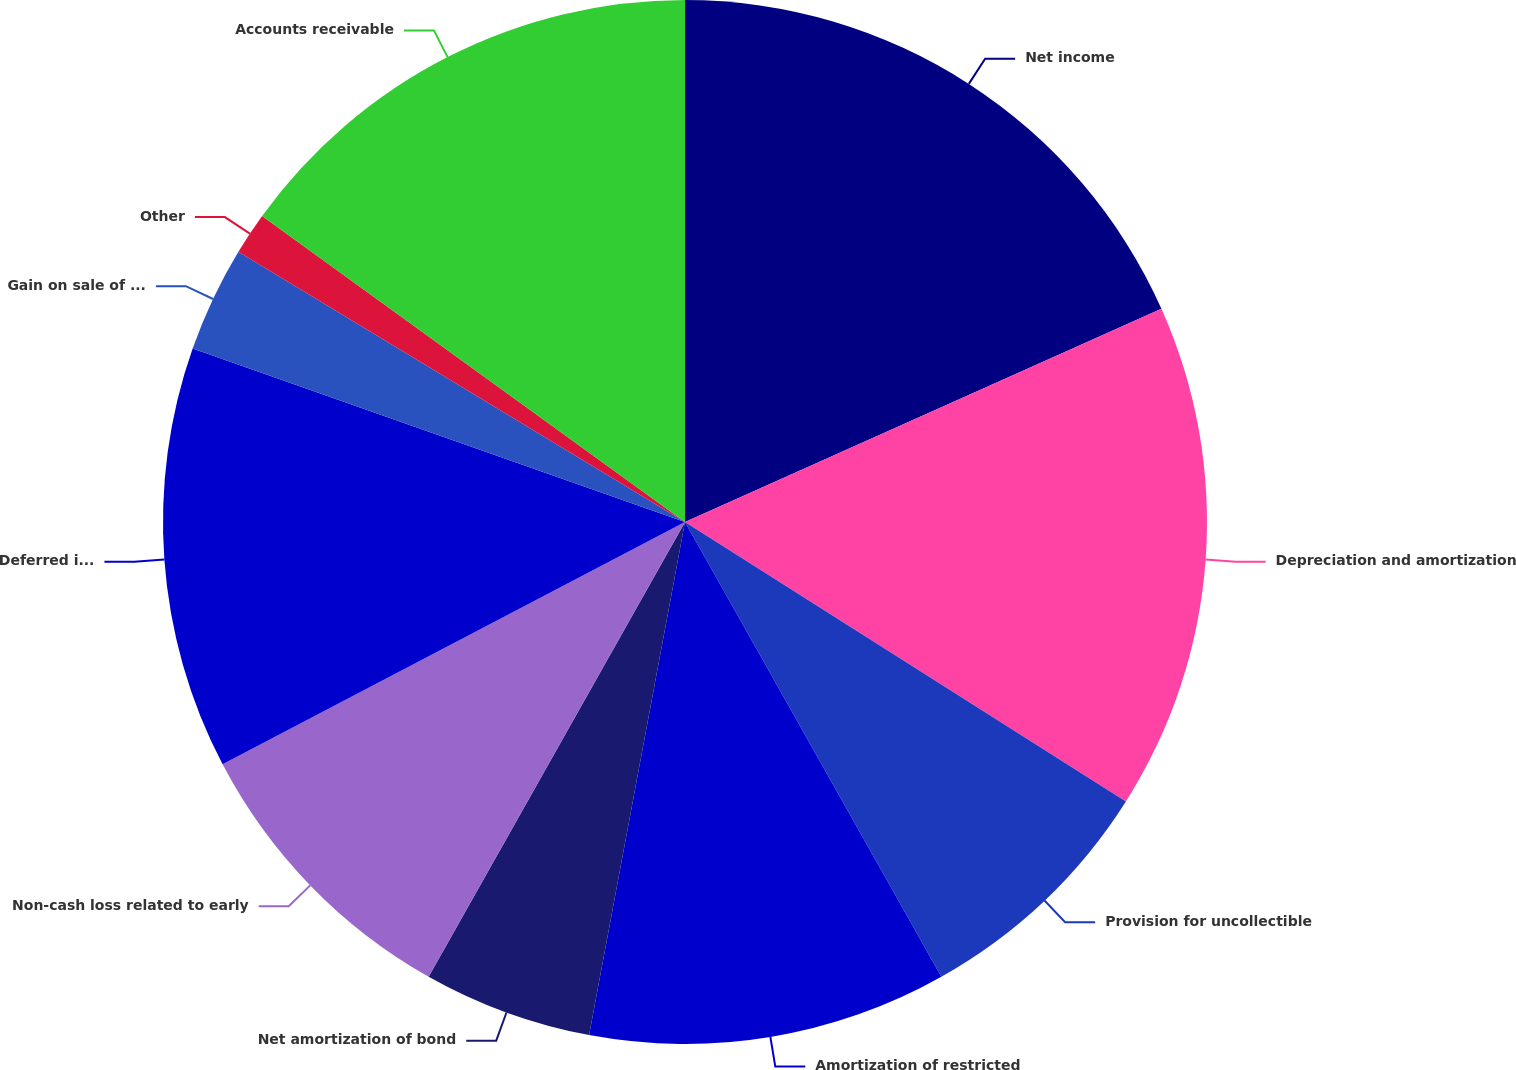<chart> <loc_0><loc_0><loc_500><loc_500><pie_chart><fcel>Net income<fcel>Depreciation and amortization<fcel>Provision for uncollectible<fcel>Amortization of restricted<fcel>Net amortization of bond<fcel>Non-cash loss related to early<fcel>Deferred income tax provision<fcel>Gain on sale of an investment<fcel>Other<fcel>Accounts receivable<nl><fcel>18.3%<fcel>15.69%<fcel>7.84%<fcel>11.11%<fcel>5.23%<fcel>9.15%<fcel>13.07%<fcel>3.27%<fcel>1.31%<fcel>15.03%<nl></chart> 